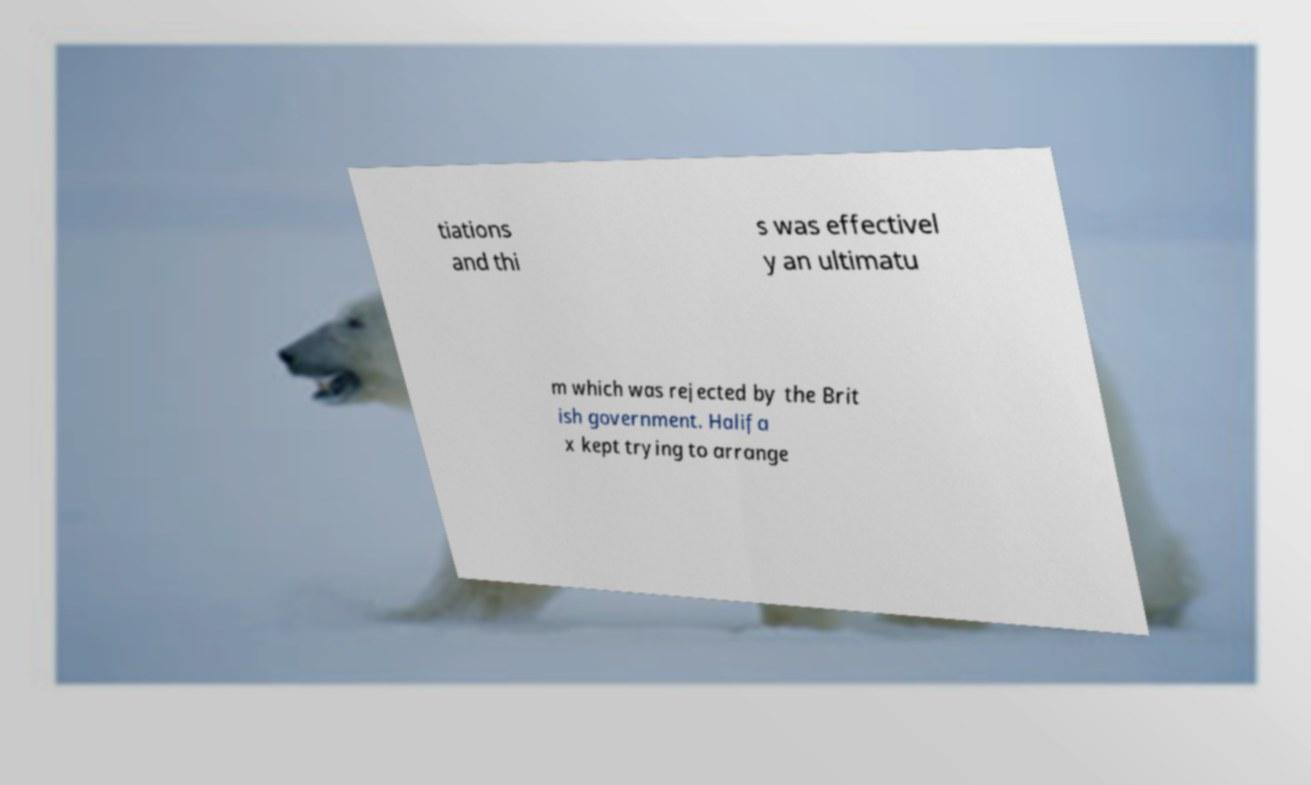For documentation purposes, I need the text within this image transcribed. Could you provide that? tiations and thi s was effectivel y an ultimatu m which was rejected by the Brit ish government. Halifa x kept trying to arrange 